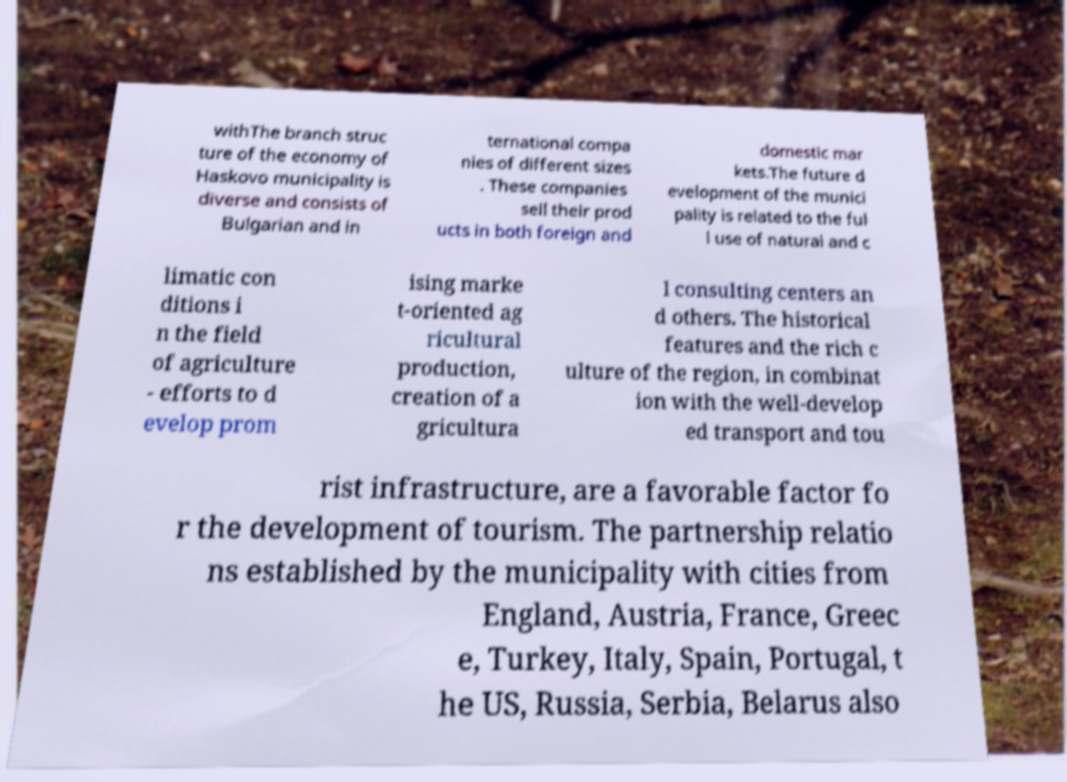What messages or text are displayed in this image? I need them in a readable, typed format. withThe branch struc ture of the economy of Haskovo municipality is diverse and consists of Bulgarian and in ternational compa nies of different sizes . These companies sell their prod ucts in both foreign and domestic mar kets.The future d evelopment of the munici pality is related to the ful l use of natural and c limatic con ditions i n the field of agriculture - efforts to d evelop prom ising marke t-oriented ag ricultural production, creation of a gricultura l consulting centers an d others. The historical features and the rich c ulture of the region, in combinat ion with the well-develop ed transport and tou rist infrastructure, are a favorable factor fo r the development of tourism. The partnership relatio ns established by the municipality with cities from England, Austria, France, Greec e, Turkey, Italy, Spain, Portugal, t he US, Russia, Serbia, Belarus also 